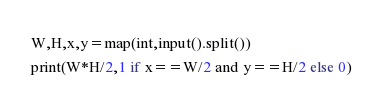Convert code to text. <code><loc_0><loc_0><loc_500><loc_500><_Python_>W,H,x,y=map(int,input().split())
print(W*H/2,1 if x==W/2 and y==H/2 else 0)</code> 